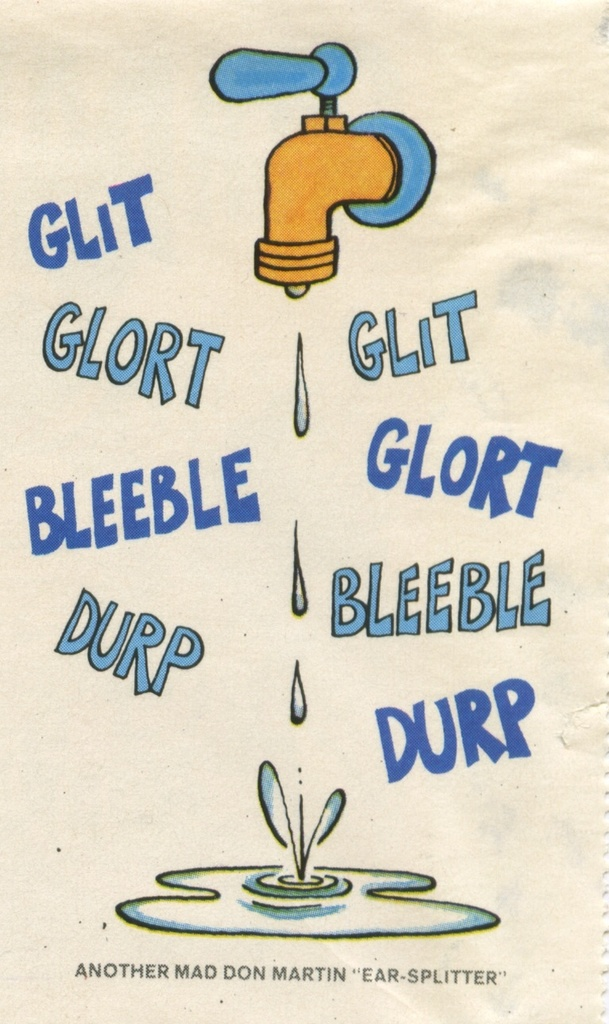How does the artistic style of the faucet contribute to the overall humor of this illustration? The faucet is drawn in a simplistic, exaggerated cartoon style with a bright blue color and a bulbous shape, which by itself adds a whimsical and non-serious tone to the illustration. Such a style is effective for comic art, as it departs from realism and allows for more expressive and humorous interpretations of everyday objects, enhancing the overall comedic effect. 